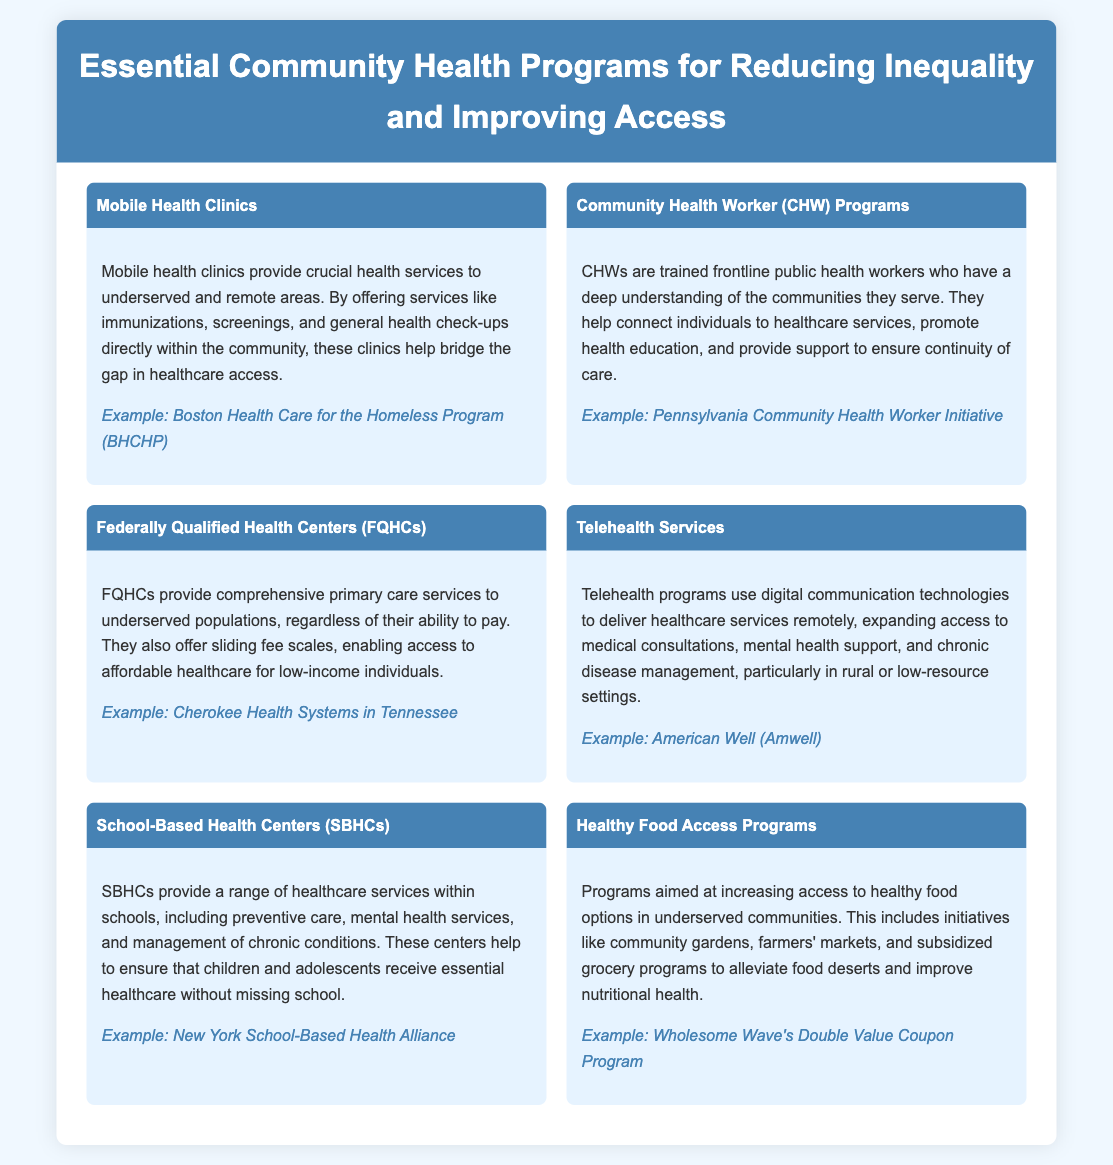What is a key feature of Mobile Health Clinics? Mobile Health Clinics provide crucial health services to underserved and remote areas, helping bridge the gap in healthcare access.
Answer: Crucial health services What does CHWs stand for? CHWs refer to Community Health Workers, who are trained frontline public health workers that assist individuals in accessing healthcare services.
Answer: Community Health Workers Which program offers sliding fee scales for low-income individuals? Federally Qualified Health Centers (FQHCs) provide sliding fee scales, enabling access to affordable healthcare for low-income individuals.
Answer: Federally Qualified Health Centers (FQHCs) What is an example of a Telehealth service provider? An example of a Telehealth service provider mentioned is American Well (Amwell).
Answer: American Well What type of centers provides healthcare services within schools? School-Based Health Centers (SBHCs) provide a range of healthcare services within schools.
Answer: School-Based Health Centers (SBHCs) Which program focuses on alleviating food deserts? Healthy Food Access Programs aim at increasing access to healthy food options and alleviating food deserts.
Answer: Healthy Food Access Programs What type of health support do Mobile Health Clinics offer? Mobile Health Clinics offer immunizations, screenings, and general health check-ups within communities.
Answer: Immunizations, screenings, general health check-ups What is one benefit of Community Health Worker (CHW) Programs? One benefit is that CHWs help connect individuals to healthcare services and promote health education.
Answer: Connection to healthcare services What is the main objective of Federally Qualified Health Centers (FQHCs)? The main objective is to provide comprehensive primary care services to underserved populations regardless of their ability to pay.
Answer: Comprehensive primary care services 